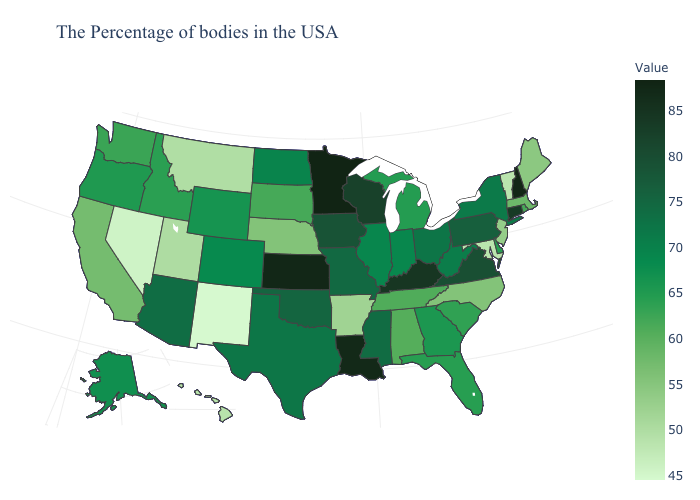Among the states that border Virginia , which have the lowest value?
Concise answer only. Maryland. Among the states that border Maine , which have the lowest value?
Give a very brief answer. New Hampshire. Does Minnesota have the lowest value in the USA?
Quick response, please. No. Which states have the lowest value in the USA?
Quick response, please. New Mexico. Which states hav the highest value in the Northeast?
Be succinct. New Hampshire. Which states hav the highest value in the MidWest?
Answer briefly. Minnesota. Is the legend a continuous bar?
Write a very short answer. Yes. 